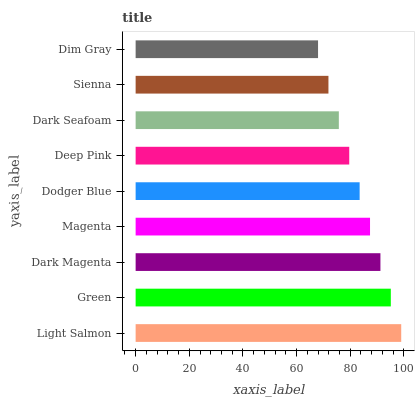Is Dim Gray the minimum?
Answer yes or no. Yes. Is Light Salmon the maximum?
Answer yes or no. Yes. Is Green the minimum?
Answer yes or no. No. Is Green the maximum?
Answer yes or no. No. Is Light Salmon greater than Green?
Answer yes or no. Yes. Is Green less than Light Salmon?
Answer yes or no. Yes. Is Green greater than Light Salmon?
Answer yes or no. No. Is Light Salmon less than Green?
Answer yes or no. No. Is Dodger Blue the high median?
Answer yes or no. Yes. Is Dodger Blue the low median?
Answer yes or no. Yes. Is Deep Pink the high median?
Answer yes or no. No. Is Green the low median?
Answer yes or no. No. 